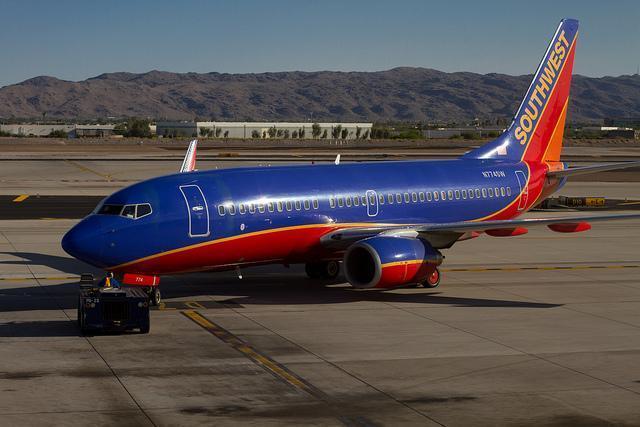Does the caption "The person is far from the airplane." correctly depict the image?
Answer yes or no. No. 